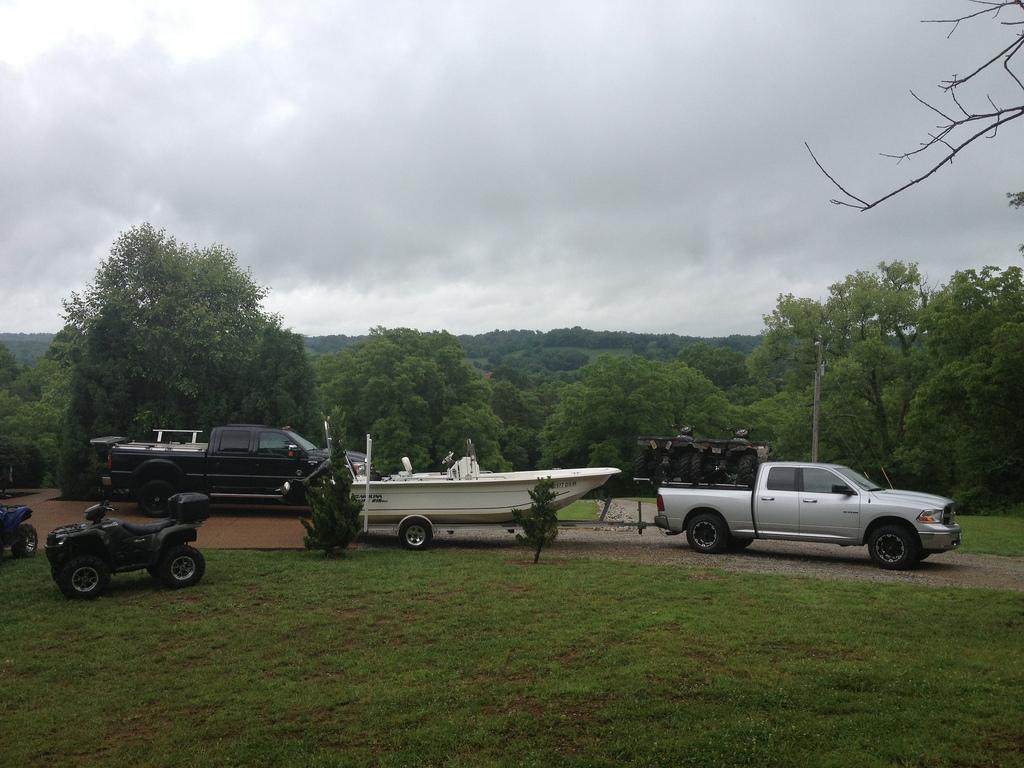How many trucks are parked in the driveway?
Give a very brief answer. 2. 